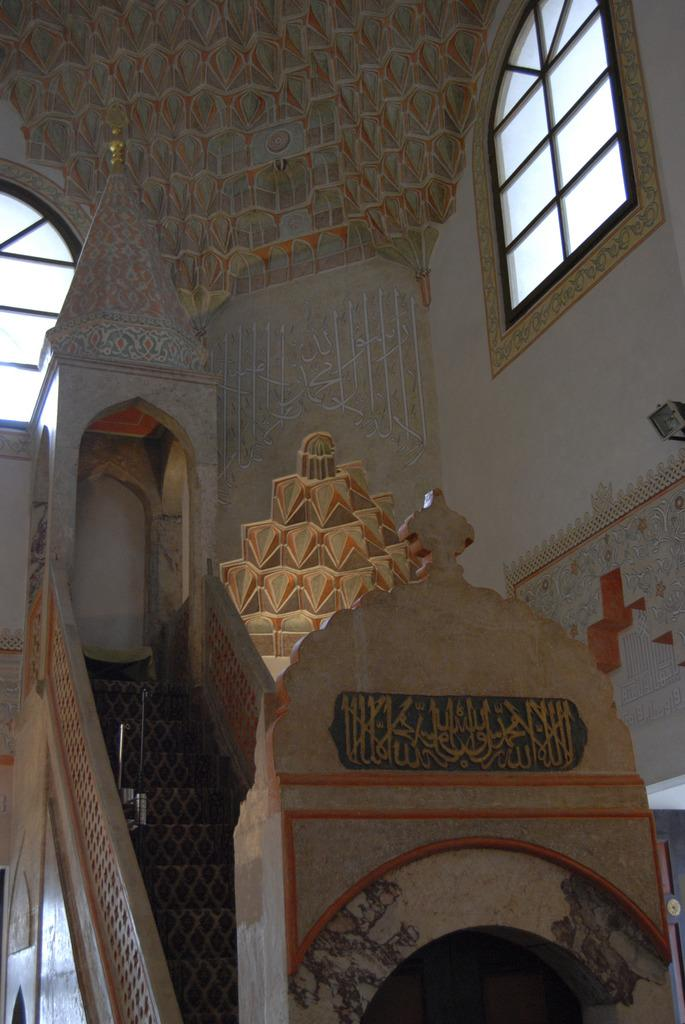What type of structure can be seen in the image? There is a wall in the image. What feature is present on the wall? The wall has windows. What architectural element is visible in the image? There are steps in the image. What other objects can be seen in the image? There are other objects present in the image. What type of creature is sitting on the wall in the image? There is no creature present on the wall in the image. What color is the coat hanging on the wall in the image? There is no coat present on the wall in the image. 